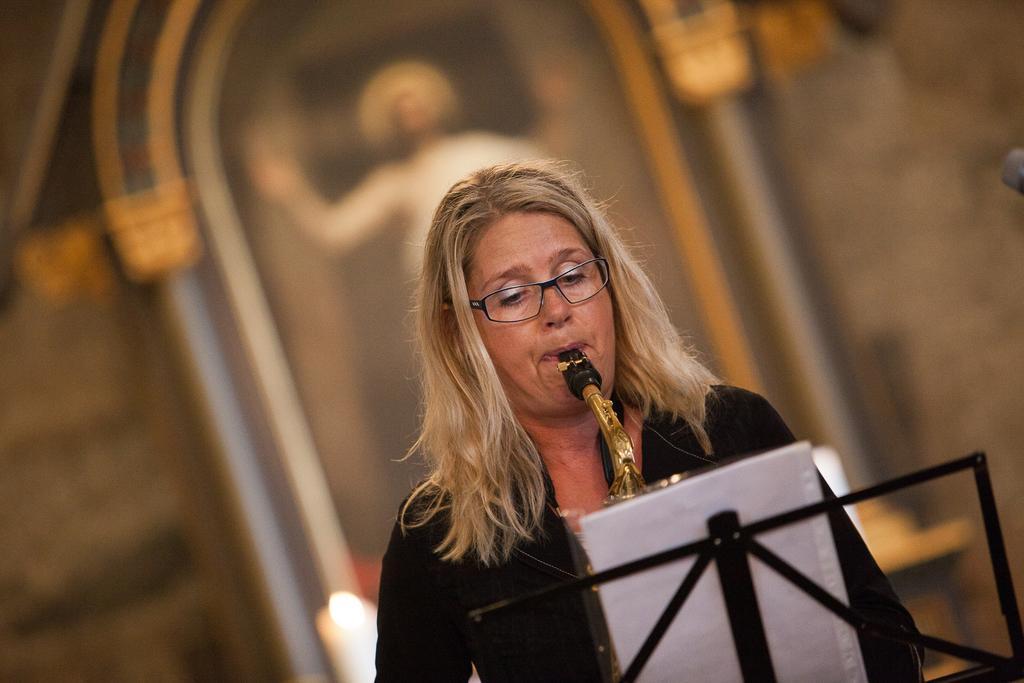In one or two sentences, can you explain what this image depicts? There is a woman playing musical instrument,in front of this woman we can see object on stand. Background it is blur. 